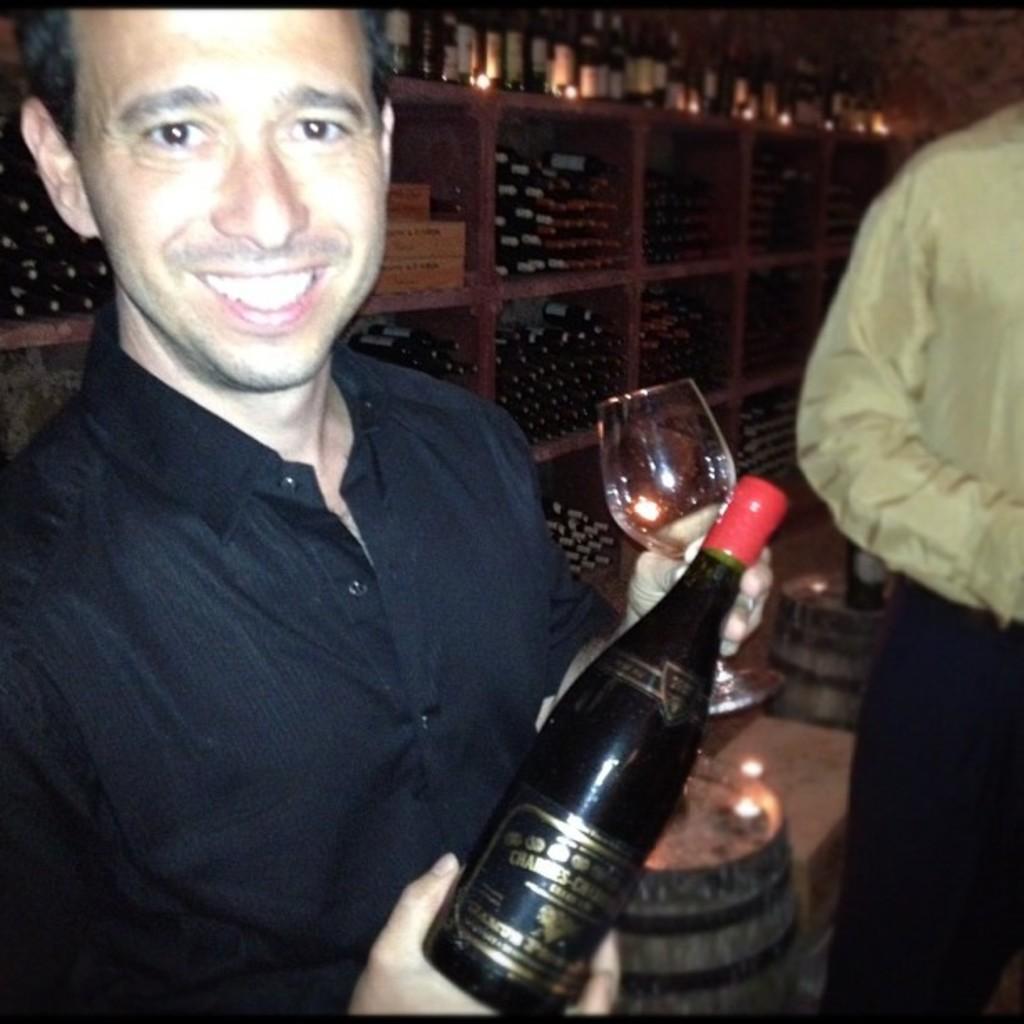In one or two sentences, can you explain what this image depicts? In this image, a person is holding a wine glass and bottle. And he is smiling. And right side, we can see a human body. At the background, there is a big shelf that is filled with bottles. And at the bottom,we can see a wooden barrel. 